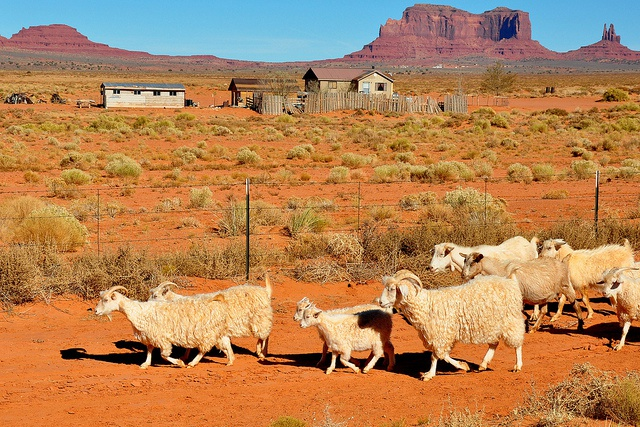Describe the objects in this image and their specific colors. I can see sheep in lightblue, tan, and beige tones, sheep in lightblue, tan, beige, and black tones, sheep in lightblue, tan, maroon, and black tones, sheep in lightblue and tan tones, and sheep in lightblue, tan, and brown tones in this image. 